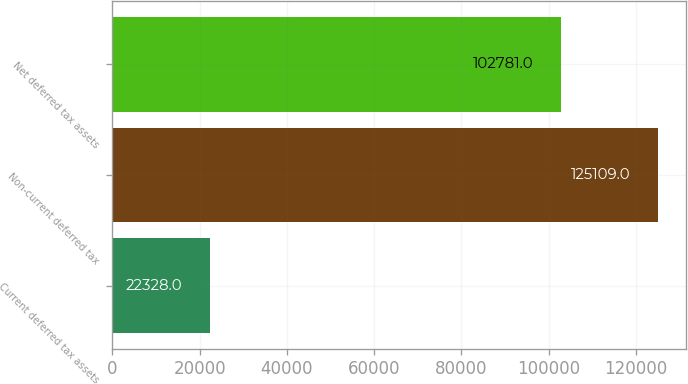<chart> <loc_0><loc_0><loc_500><loc_500><bar_chart><fcel>Current deferred tax assets<fcel>Non-current deferred tax<fcel>Net deferred tax assets<nl><fcel>22328<fcel>125109<fcel>102781<nl></chart> 